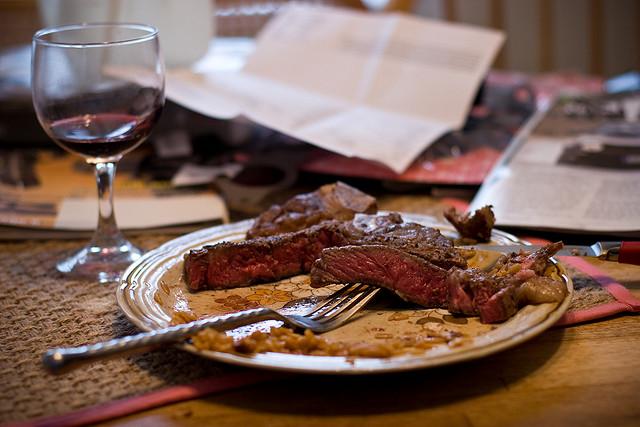How many forks are on the plate?
Be succinct. 1. Where is the fork?
Give a very brief answer. Plate. What clear liquid is in the glass?
Write a very short answer. Wine. What holiday is that meat usually served on?
Give a very brief answer. Easter. What utensil is shown?
Be succinct. Fork. What meat is this?
Give a very brief answer. Steak. 